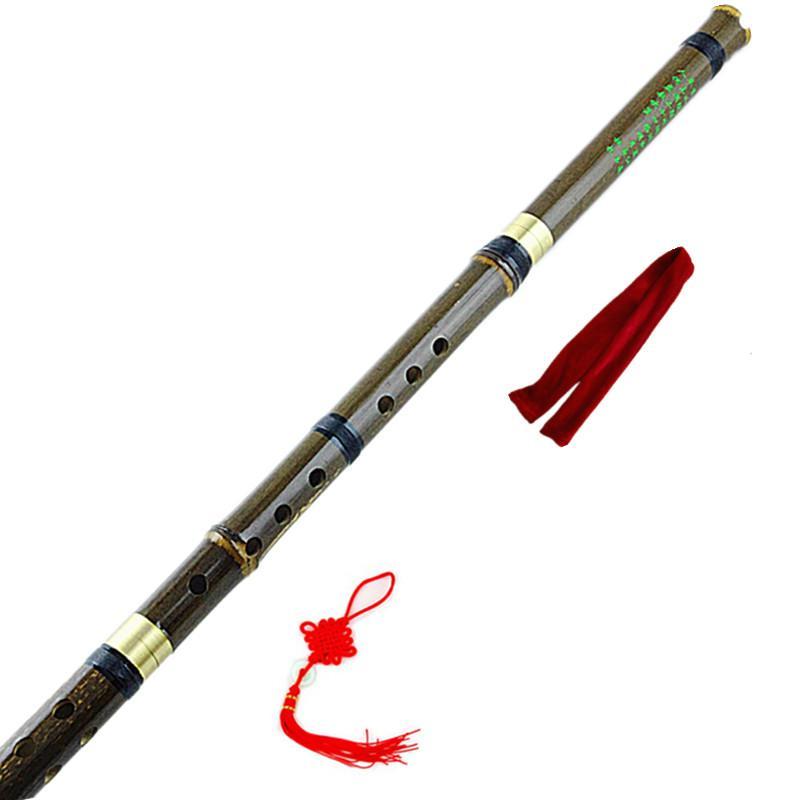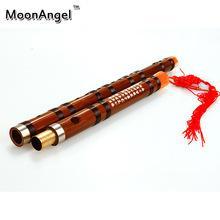The first image is the image on the left, the second image is the image on the right. Examine the images to the left and right. Is the description "There are two disassembled flutes." accurate? Answer yes or no. No. The first image is the image on the left, the second image is the image on the right. For the images shown, is this caption "The left image shows two flutes side-by-side, displayed diagonally with ends at the upper right." true? Answer yes or no. No. 